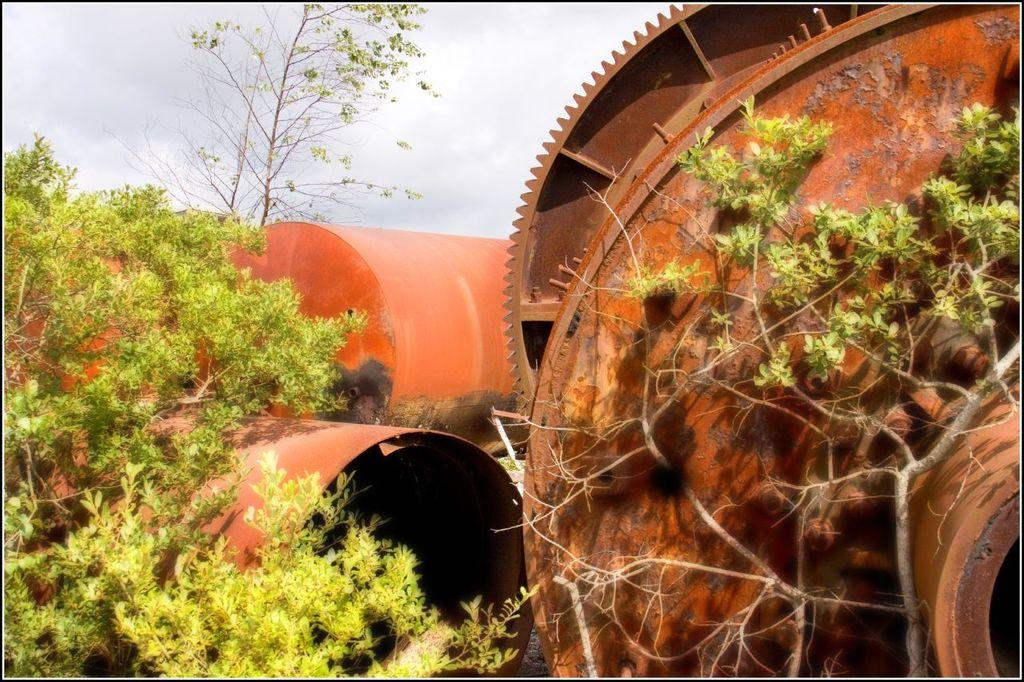What type of object is the main subject in the image? There is a metal tank in the image. Are there any other metal objects present in the image? Yes, there are metal objects in the image. What type of natural environment can be seen in the image? Trees are visible in the image. How would you describe the weather based on the image? The sky is cloudy in the image. What type of scent can be detected from the dolls in the image? There are no dolls present in the image, so it is not possible to detect any scent from them. 